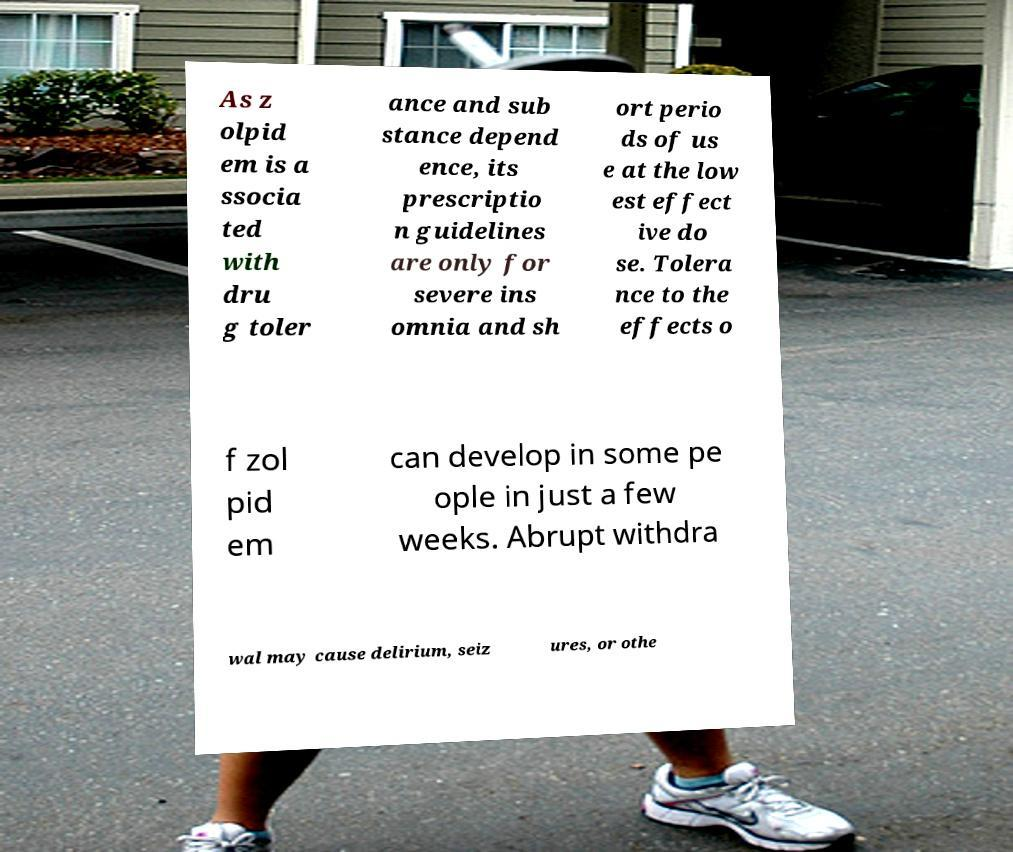What messages or text are displayed in this image? I need them in a readable, typed format. As z olpid em is a ssocia ted with dru g toler ance and sub stance depend ence, its prescriptio n guidelines are only for severe ins omnia and sh ort perio ds of us e at the low est effect ive do se. Tolera nce to the effects o f zol pid em can develop in some pe ople in just a few weeks. Abrupt withdra wal may cause delirium, seiz ures, or othe 